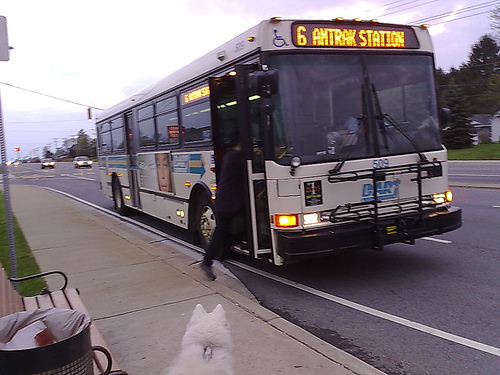Please provide the bounding box coordinate of the region this sentence describes: the wipers are black. The black wipers are located within the coordinates [0.63, 0.33, 0.86, 0.45], precisely covering the area necessary to capture this often overlooked but essential vehicle feature. 